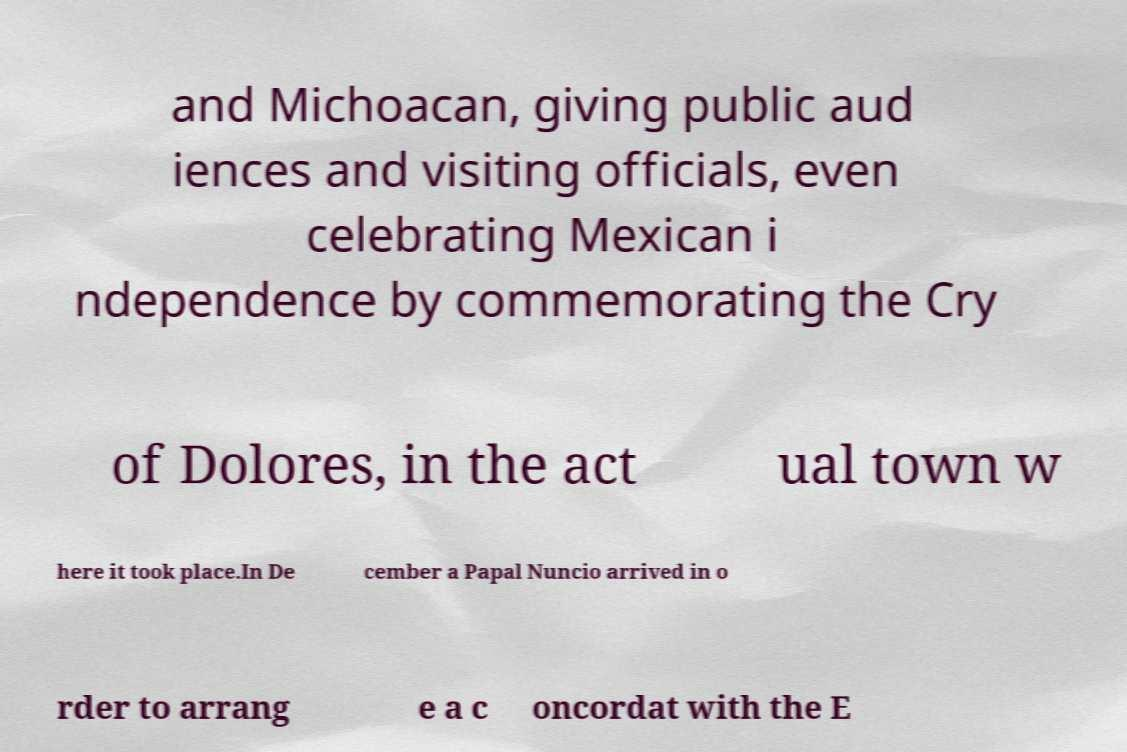For documentation purposes, I need the text within this image transcribed. Could you provide that? and Michoacan, giving public aud iences and visiting officials, even celebrating Mexican i ndependence by commemorating the Cry of Dolores, in the act ual town w here it took place.In De cember a Papal Nuncio arrived in o rder to arrang e a c oncordat with the E 